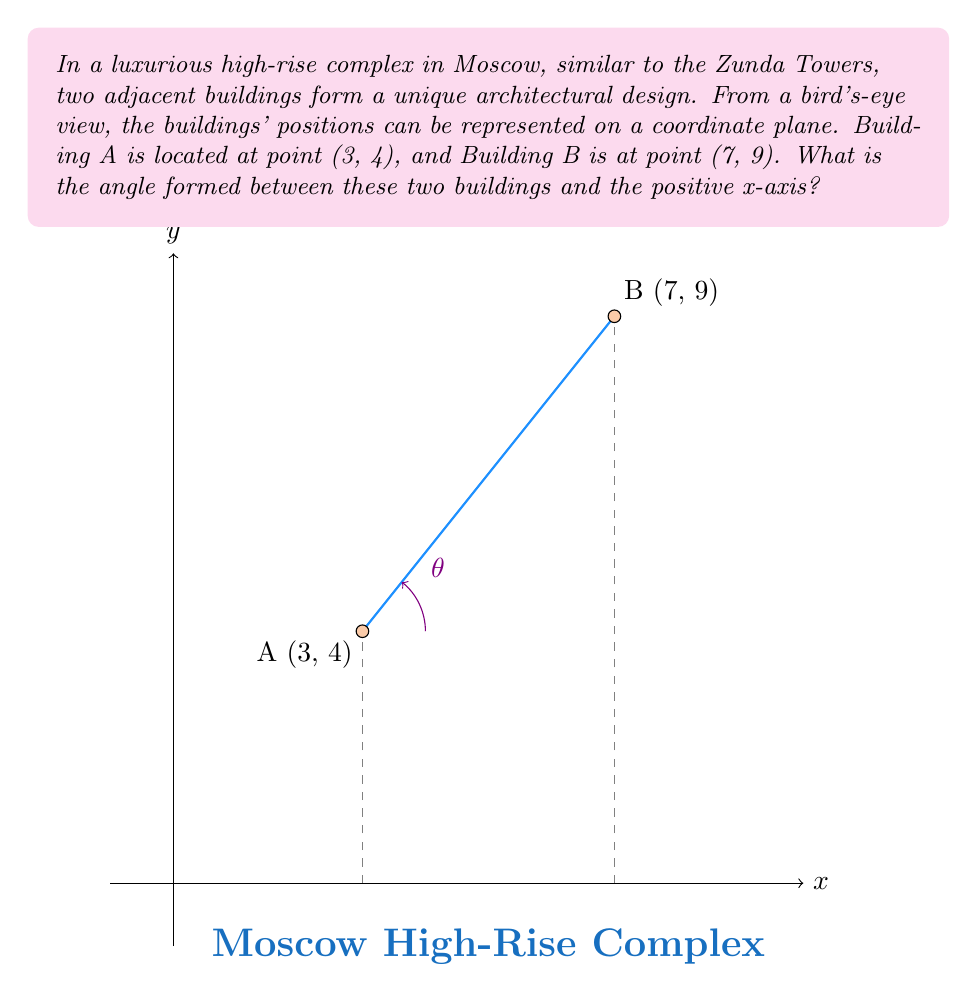Can you solve this math problem? To find the angle between the line connecting the two buildings and the positive x-axis, we can follow these steps:

1) First, we need to calculate the slope of the line connecting points A and B:

   $m = \frac{y_2 - y_1}{x_2 - x_1} = \frac{9 - 4}{7 - 3} = \frac{5}{4} = 1.25$

2) The angle θ between a line and the positive x-axis is related to its slope by the equation:

   $\theta = \arctan(m)$

3) Substituting our slope:

   $\theta = \arctan(1.25)$

4) Using a calculator or mathematical software:

   $\theta \approx 51.34°$

5) To get a more precise answer, we can use the atan2 function, which takes into account the direction of the line:

   $\theta = \arctan2(y_2 - y_1, x_2 - x_1) = \arctan2(9 - 4, 7 - 3) = \arctan2(5, 4)$

6) This gives us the same result:

   $\theta \approx 51.34°$

The angle is measured counterclockwise from the positive x-axis.
Answer: $51.34°$ 